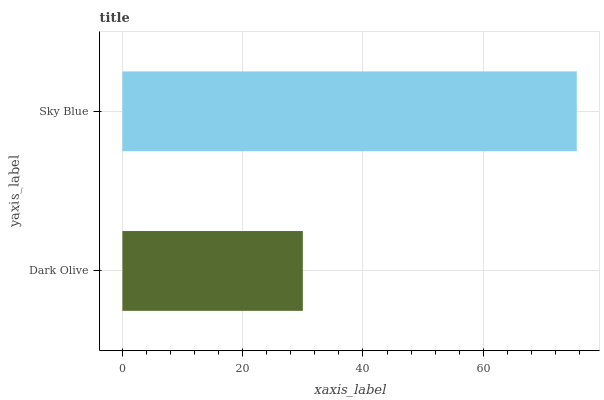Is Dark Olive the minimum?
Answer yes or no. Yes. Is Sky Blue the maximum?
Answer yes or no. Yes. Is Sky Blue the minimum?
Answer yes or no. No. Is Sky Blue greater than Dark Olive?
Answer yes or no. Yes. Is Dark Olive less than Sky Blue?
Answer yes or no. Yes. Is Dark Olive greater than Sky Blue?
Answer yes or no. No. Is Sky Blue less than Dark Olive?
Answer yes or no. No. Is Sky Blue the high median?
Answer yes or no. Yes. Is Dark Olive the low median?
Answer yes or no. Yes. Is Dark Olive the high median?
Answer yes or no. No. Is Sky Blue the low median?
Answer yes or no. No. 